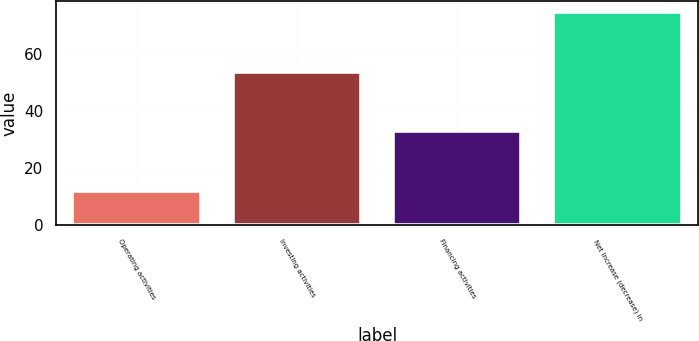<chart> <loc_0><loc_0><loc_500><loc_500><bar_chart><fcel>Operating activities<fcel>Investing activities<fcel>Financing activities<fcel>Net increase (decrease) in<nl><fcel>12<fcel>54<fcel>33<fcel>75<nl></chart> 